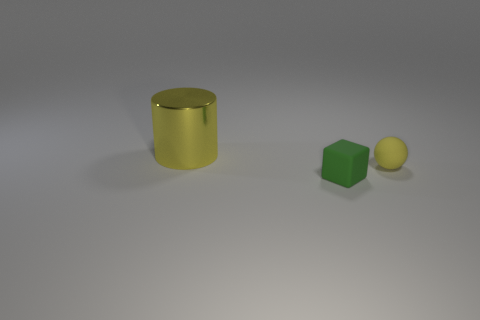Are there any other things that are the same size as the metal cylinder?
Give a very brief answer. No. What number of objects have the same color as the tiny matte block?
Offer a terse response. 0. How big is the yellow thing in front of the large cylinder?
Provide a short and direct response. Small. What shape is the tiny rubber object that is behind the small matte object that is in front of the small rubber object that is behind the small green rubber block?
Your answer should be compact. Sphere. There is a object that is left of the yellow rubber thing and behind the green object; what shape is it?
Your answer should be compact. Cylinder. Is there a matte ball of the same size as the metallic object?
Offer a terse response. No. There is a yellow thing in front of the yellow cylinder; is it the same shape as the yellow metallic object?
Make the answer very short. No. Do the tiny yellow rubber thing and the large yellow metal object have the same shape?
Give a very brief answer. No. Is there another yellow shiny object that has the same shape as the shiny thing?
Your response must be concise. No. The yellow object behind the yellow object right of the big object is what shape?
Your answer should be compact. Cylinder. 